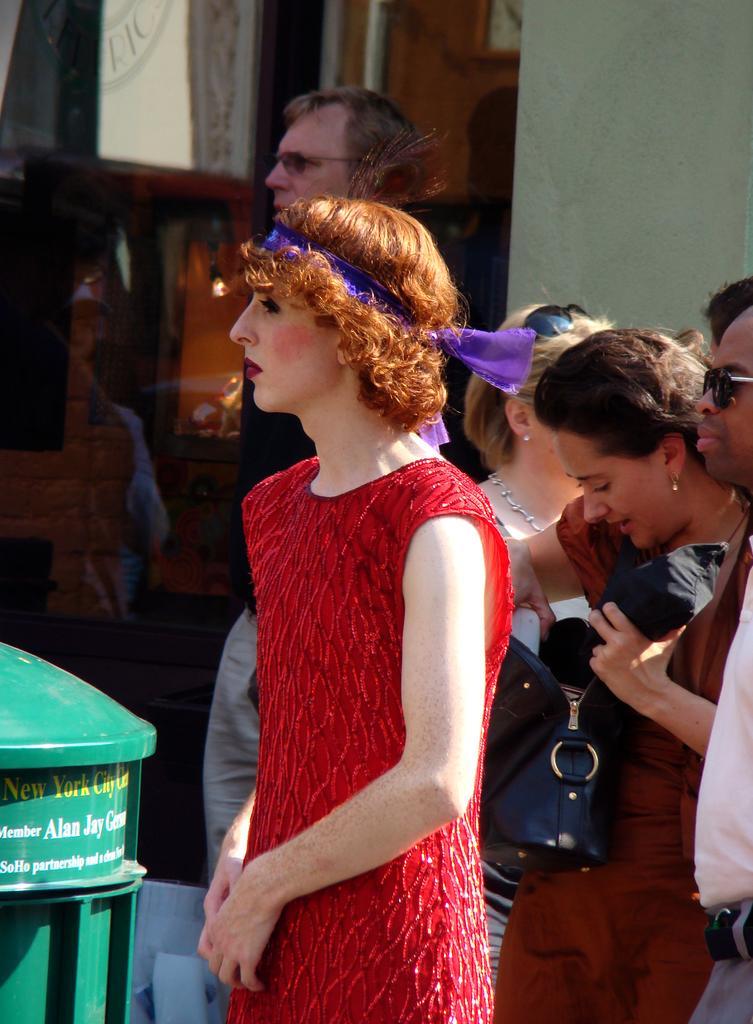In one or two sentences, can you explain what this image depicts? In the picture we can see a woman standing on the path and she is wearing a red dress and has a brown hair and a blue ribbon for the hair and beside her we can see a post box which is green in color and in the background we can see some people are standing near the wall. 